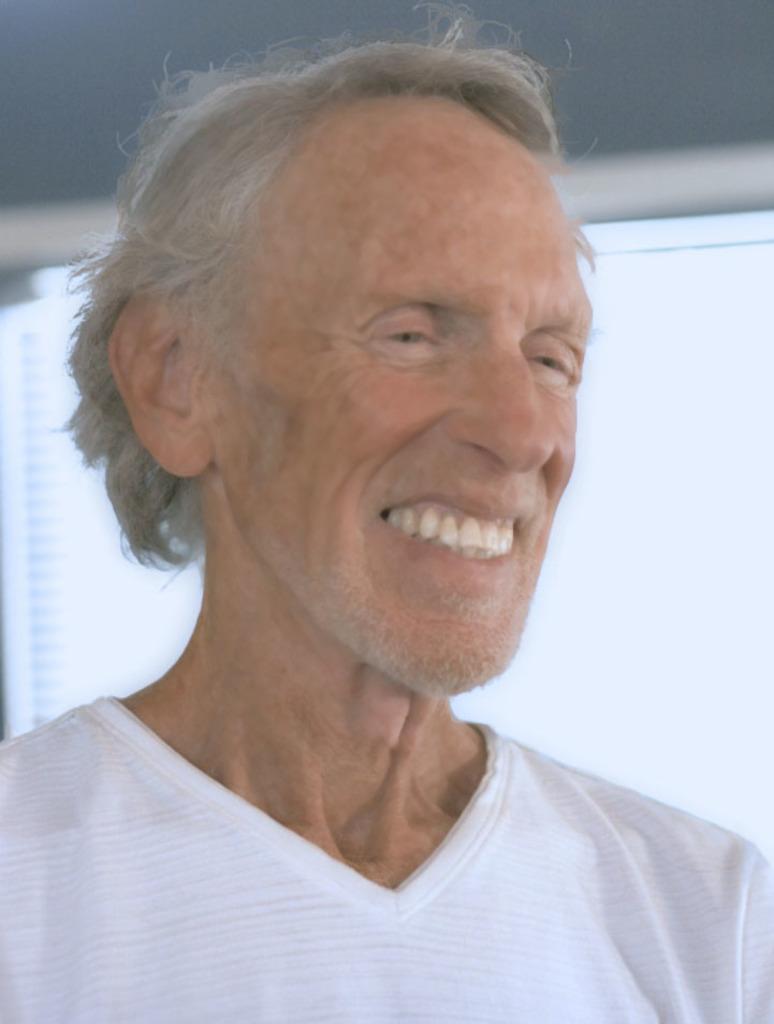In one or two sentences, can you explain what this image depicts? In this picture we can see a person, he is smiling and in the background we can see an object. 